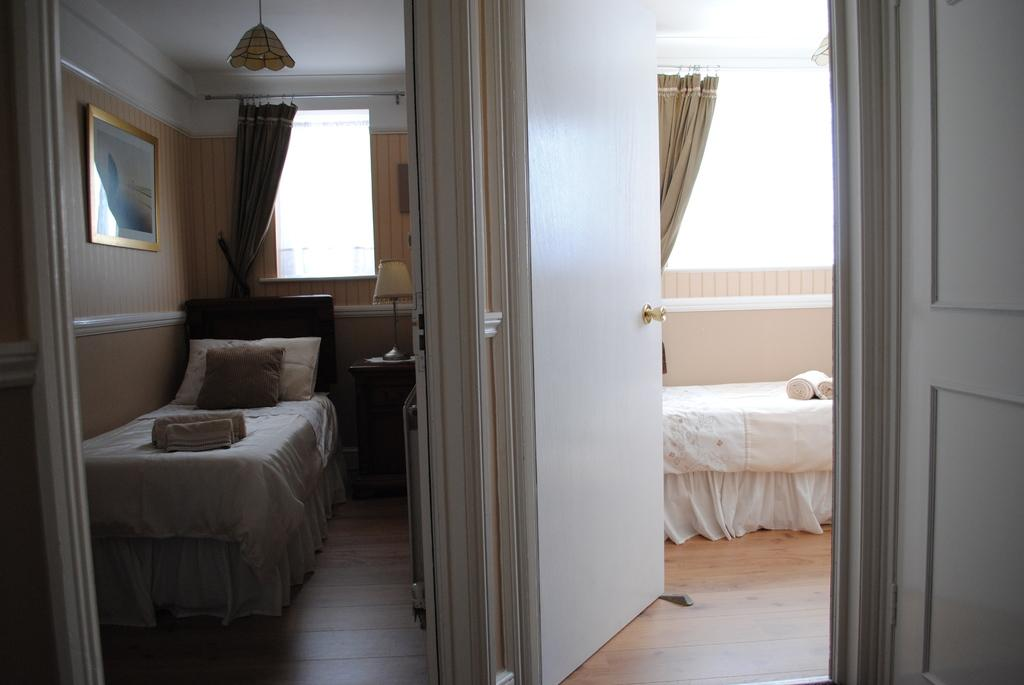How many beds are visible in the image? There are two white beds in the image. Are the beds located in the same room or different rooms? The beds are in two different rooms. What type of fowl can be seen on the beds in the image? There are no fowl present on the beds or in the image. What is the profit margin of the beds in the image? The image does not provide any information about the profit margin of the beds. 